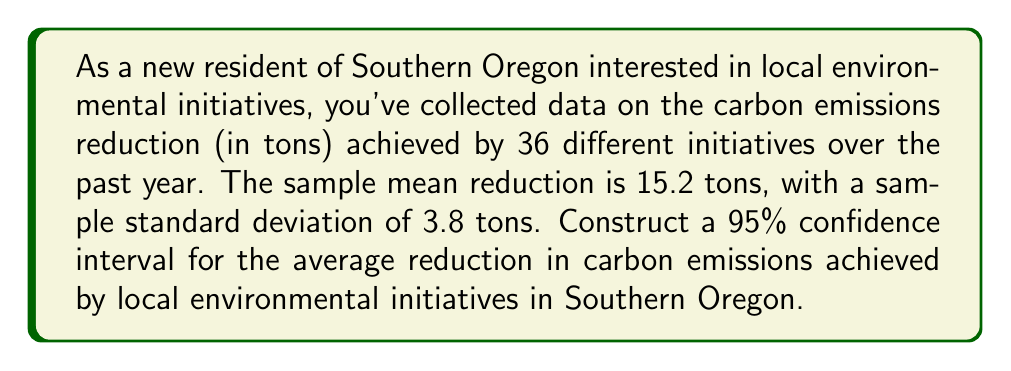Help me with this question. To construct a 95% confidence interval for the average reduction in carbon emissions, we'll follow these steps:

1. Identify the relevant information:
   - Sample size: $n = 36$
   - Sample mean: $\bar{x} = 15.2$ tons
   - Sample standard deviation: $s = 3.8$ tons
   - Confidence level: 95% (α = 0.05)

2. Determine the critical value:
   For a 95% confidence level with 35 degrees of freedom (n-1), we use the t-distribution. The critical value is $t_{0.025, 35} = 2.030$.

3. Calculate the standard error of the mean:
   $SE = \frac{s}{\sqrt{n}} = \frac{3.8}{\sqrt{36}} = \frac{3.8}{6} = 0.633$

4. Calculate the margin of error:
   $E = t_{0.025, 35} \cdot SE = 2.030 \cdot 0.633 = 1.285$

5. Construct the confidence interval:
   $CI = \bar{x} \pm E = 15.2 \pm 1.285$

   Lower bound: $15.2 - 1.285 = 13.915$
   Upper bound: $15.2 + 1.285 = 16.485$

Therefore, the 95% confidence interval for the average reduction in carbon emissions achieved by local environmental initiatives in Southern Oregon is (13.915, 16.485) tons.
Answer: (13.915, 16.485) tons 